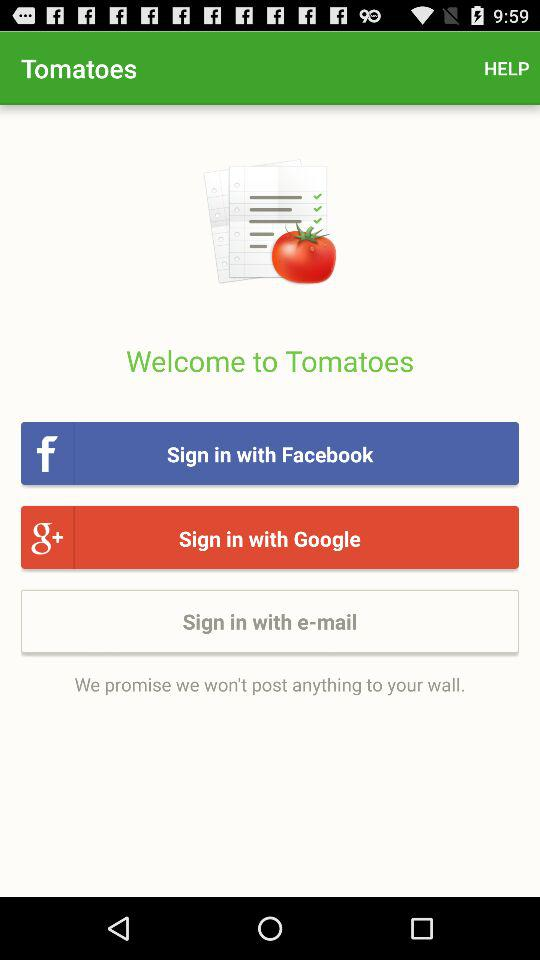How do you sign up?
When the provided information is insufficient, respond with <no answer>. <no answer> 